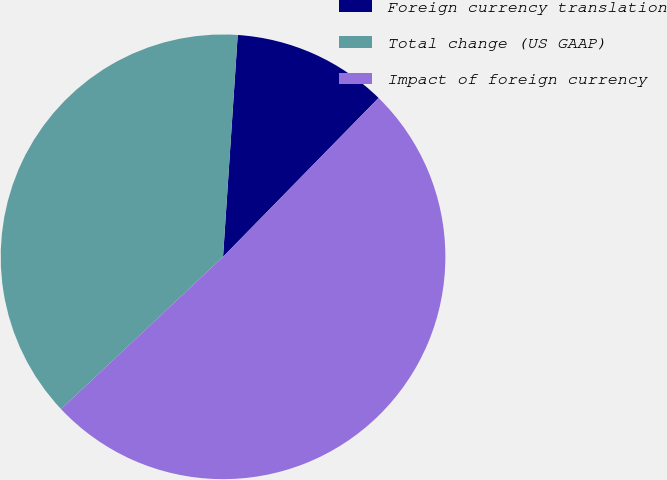Convert chart to OTSL. <chart><loc_0><loc_0><loc_500><loc_500><pie_chart><fcel>Foreign currency translation<fcel>Total change (US GAAP)<fcel>Impact of foreign currency<nl><fcel>11.28%<fcel>38.06%<fcel>50.66%<nl></chart> 